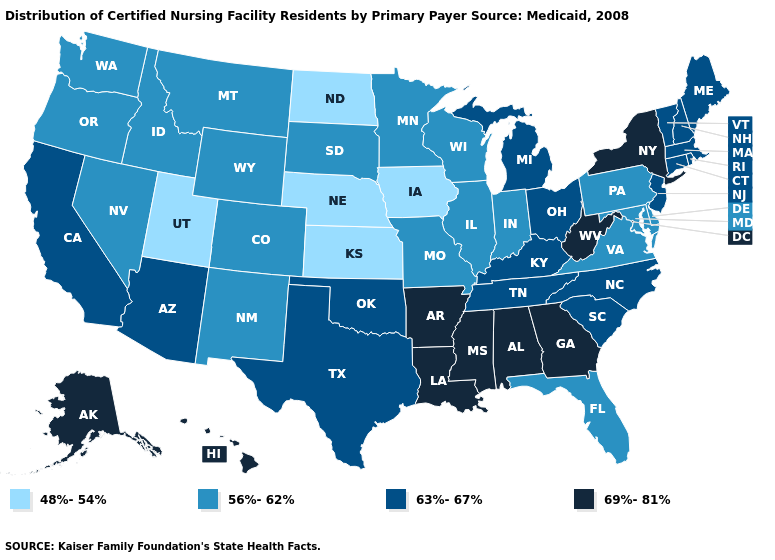Does Illinois have the lowest value in the USA?
Write a very short answer. No. What is the highest value in the South ?
Short answer required. 69%-81%. Name the states that have a value in the range 69%-81%?
Short answer required. Alabama, Alaska, Arkansas, Georgia, Hawaii, Louisiana, Mississippi, New York, West Virginia. Among the states that border Maryland , which have the lowest value?
Give a very brief answer. Delaware, Pennsylvania, Virginia. Is the legend a continuous bar?
Concise answer only. No. Does Indiana have a lower value than Idaho?
Give a very brief answer. No. Name the states that have a value in the range 56%-62%?
Answer briefly. Colorado, Delaware, Florida, Idaho, Illinois, Indiana, Maryland, Minnesota, Missouri, Montana, Nevada, New Mexico, Oregon, Pennsylvania, South Dakota, Virginia, Washington, Wisconsin, Wyoming. Name the states that have a value in the range 63%-67%?
Give a very brief answer. Arizona, California, Connecticut, Kentucky, Maine, Massachusetts, Michigan, New Hampshire, New Jersey, North Carolina, Ohio, Oklahoma, Rhode Island, South Carolina, Tennessee, Texas, Vermont. Which states hav the highest value in the West?
Answer briefly. Alaska, Hawaii. Does the map have missing data?
Answer briefly. No. Among the states that border North Dakota , which have the highest value?
Write a very short answer. Minnesota, Montana, South Dakota. Does Massachusetts have a higher value than Vermont?
Give a very brief answer. No. Which states have the highest value in the USA?
Concise answer only. Alabama, Alaska, Arkansas, Georgia, Hawaii, Louisiana, Mississippi, New York, West Virginia. Which states have the lowest value in the MidWest?
Quick response, please. Iowa, Kansas, Nebraska, North Dakota. Name the states that have a value in the range 56%-62%?
Write a very short answer. Colorado, Delaware, Florida, Idaho, Illinois, Indiana, Maryland, Minnesota, Missouri, Montana, Nevada, New Mexico, Oregon, Pennsylvania, South Dakota, Virginia, Washington, Wisconsin, Wyoming. 